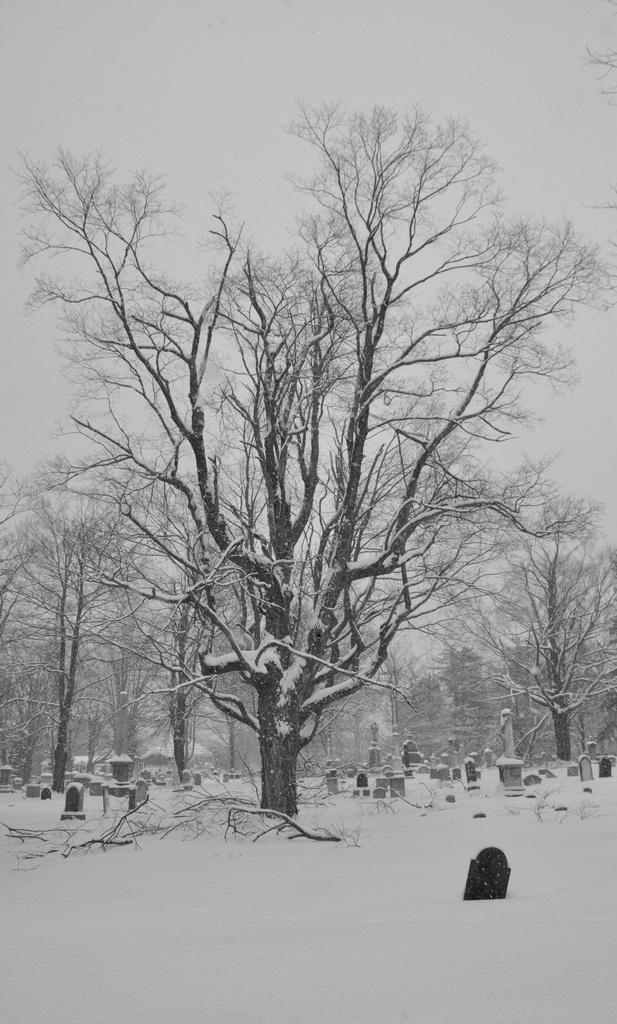What type of weather is depicted in the image? There is snow in the image, indicating cold weather. What natural elements can be seen in the image? There are trees and a sky visible in the image. What type of location is shown in the image? There is a graveyard in the image. How many babies are crawling on the ground in the image? There are no babies present in the image. 